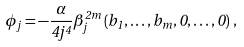<formula> <loc_0><loc_0><loc_500><loc_500>\phi _ { j } = - \frac { \alpha } { 4 j ^ { 4 } } \beta ^ { 2 m } _ { j } \left ( b _ { 1 } , \dots , b _ { m } , 0 , \dots , 0 \right ) \, ,</formula> 